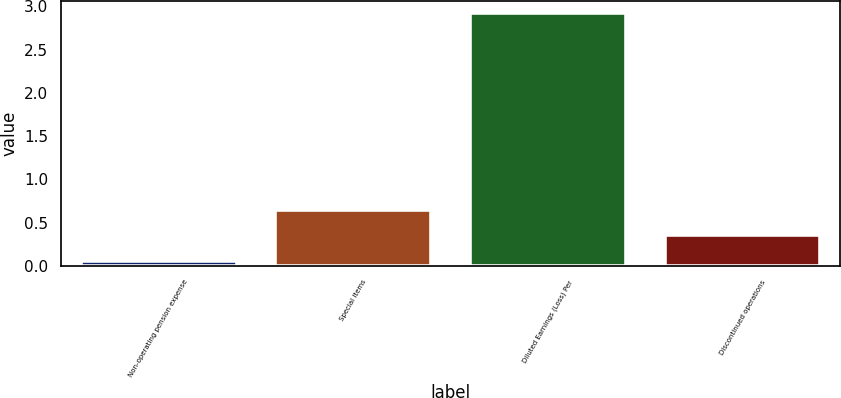Convert chart. <chart><loc_0><loc_0><loc_500><loc_500><bar_chart><fcel>Non-operating pension expense<fcel>Special items<fcel>Diluted Earnings (Loss) Per<fcel>Discontinued operations<nl><fcel>0.06<fcel>0.64<fcel>2.92<fcel>0.35<nl></chart> 